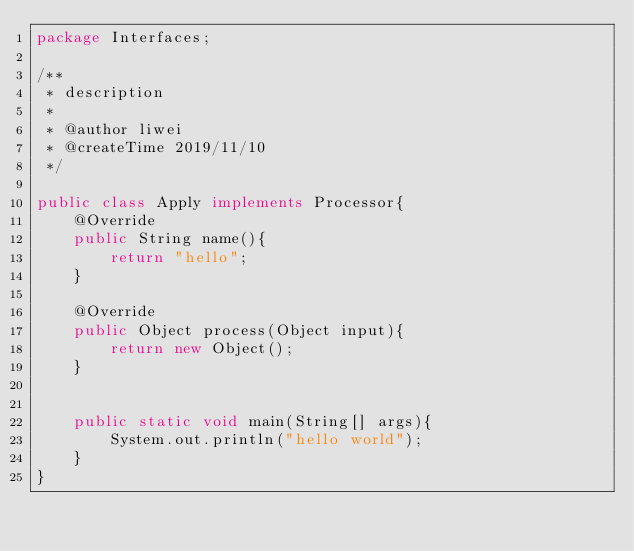<code> <loc_0><loc_0><loc_500><loc_500><_Java_>package Interfaces;

/**
 * description
 *
 * @author liwei
 * @createTime 2019/11/10
 */

public class Apply implements Processor{
    @Override
    public String name(){
        return "hello";
    }

    @Override
    public Object process(Object input){
        return new Object();
    }


    public static void main(String[] args){
        System.out.println("hello world");
    }
}
</code> 